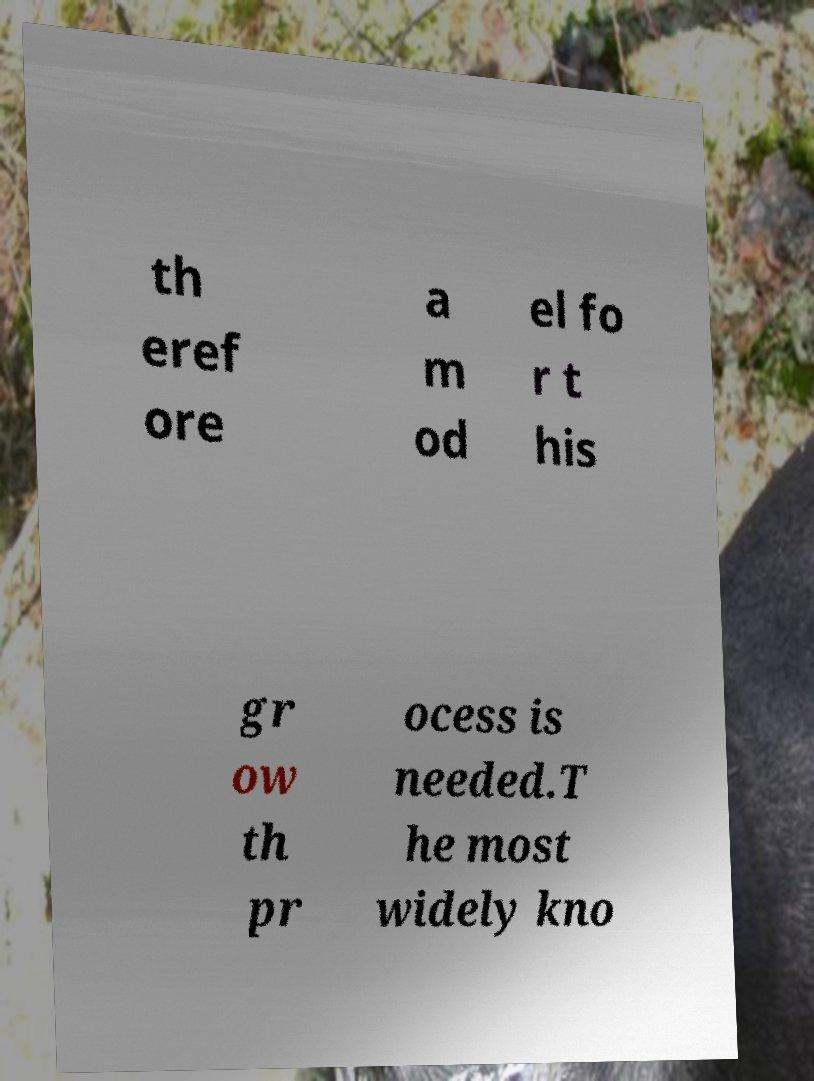I need the written content from this picture converted into text. Can you do that? th eref ore a m od el fo r t his gr ow th pr ocess is needed.T he most widely kno 